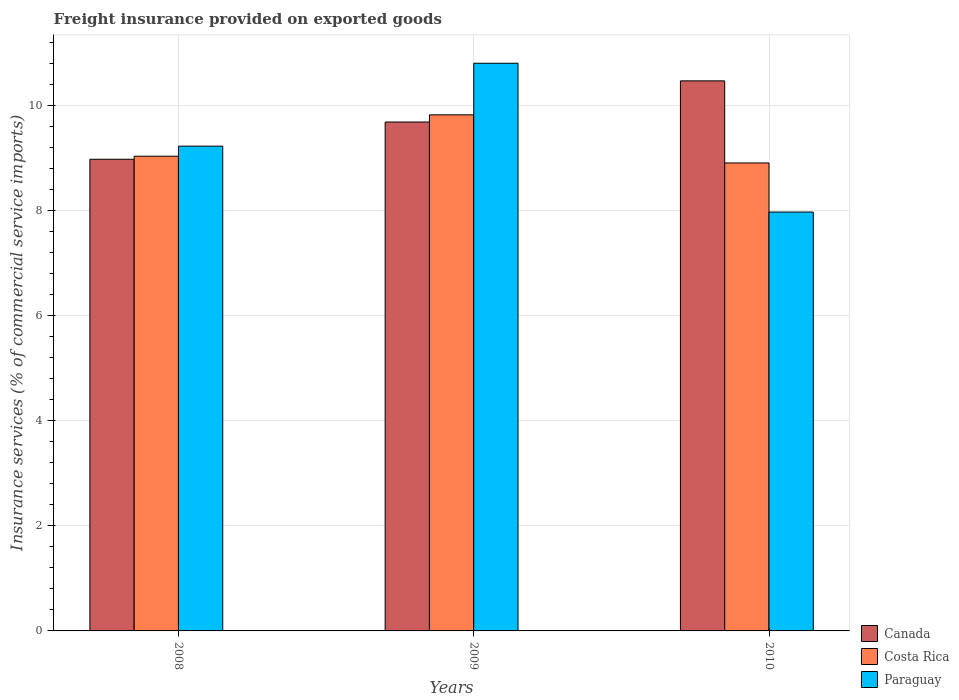Are the number of bars per tick equal to the number of legend labels?
Keep it short and to the point. Yes. Are the number of bars on each tick of the X-axis equal?
Keep it short and to the point. Yes. How many bars are there on the 2nd tick from the left?
Keep it short and to the point. 3. What is the freight insurance provided on exported goods in Canada in 2010?
Your answer should be very brief. 10.47. Across all years, what is the maximum freight insurance provided on exported goods in Canada?
Keep it short and to the point. 10.47. Across all years, what is the minimum freight insurance provided on exported goods in Costa Rica?
Your answer should be very brief. 8.91. In which year was the freight insurance provided on exported goods in Canada maximum?
Offer a very short reply. 2010. What is the total freight insurance provided on exported goods in Canada in the graph?
Your answer should be compact. 29.13. What is the difference between the freight insurance provided on exported goods in Paraguay in 2008 and that in 2009?
Provide a short and direct response. -1.58. What is the difference between the freight insurance provided on exported goods in Paraguay in 2010 and the freight insurance provided on exported goods in Costa Rica in 2009?
Provide a short and direct response. -1.85. What is the average freight insurance provided on exported goods in Paraguay per year?
Offer a very short reply. 9.34. In the year 2008, what is the difference between the freight insurance provided on exported goods in Costa Rica and freight insurance provided on exported goods in Paraguay?
Keep it short and to the point. -0.19. What is the ratio of the freight insurance provided on exported goods in Paraguay in 2008 to that in 2009?
Offer a terse response. 0.85. Is the freight insurance provided on exported goods in Canada in 2008 less than that in 2010?
Keep it short and to the point. Yes. Is the difference between the freight insurance provided on exported goods in Costa Rica in 2008 and 2010 greater than the difference between the freight insurance provided on exported goods in Paraguay in 2008 and 2010?
Your answer should be very brief. No. What is the difference between the highest and the second highest freight insurance provided on exported goods in Canada?
Make the answer very short. 0.78. What is the difference between the highest and the lowest freight insurance provided on exported goods in Paraguay?
Give a very brief answer. 2.83. Is the sum of the freight insurance provided on exported goods in Costa Rica in 2008 and 2009 greater than the maximum freight insurance provided on exported goods in Paraguay across all years?
Make the answer very short. Yes. What does the 2nd bar from the left in 2009 represents?
Make the answer very short. Costa Rica. Is it the case that in every year, the sum of the freight insurance provided on exported goods in Paraguay and freight insurance provided on exported goods in Costa Rica is greater than the freight insurance provided on exported goods in Canada?
Your answer should be compact. Yes. How many bars are there?
Ensure brevity in your answer.  9. Where does the legend appear in the graph?
Ensure brevity in your answer.  Bottom right. How many legend labels are there?
Provide a succinct answer. 3. How are the legend labels stacked?
Your answer should be very brief. Vertical. What is the title of the graph?
Give a very brief answer. Freight insurance provided on exported goods. Does "Portugal" appear as one of the legend labels in the graph?
Provide a short and direct response. No. What is the label or title of the Y-axis?
Your answer should be compact. Insurance services (% of commercial service imports). What is the Insurance services (% of commercial service imports) in Canada in 2008?
Ensure brevity in your answer.  8.98. What is the Insurance services (% of commercial service imports) in Costa Rica in 2008?
Make the answer very short. 9.04. What is the Insurance services (% of commercial service imports) of Paraguay in 2008?
Keep it short and to the point. 9.23. What is the Insurance services (% of commercial service imports) in Canada in 2009?
Your response must be concise. 9.69. What is the Insurance services (% of commercial service imports) of Costa Rica in 2009?
Provide a short and direct response. 9.82. What is the Insurance services (% of commercial service imports) of Paraguay in 2009?
Provide a short and direct response. 10.81. What is the Insurance services (% of commercial service imports) of Canada in 2010?
Your response must be concise. 10.47. What is the Insurance services (% of commercial service imports) of Costa Rica in 2010?
Your response must be concise. 8.91. What is the Insurance services (% of commercial service imports) in Paraguay in 2010?
Ensure brevity in your answer.  7.97. Across all years, what is the maximum Insurance services (% of commercial service imports) of Canada?
Ensure brevity in your answer.  10.47. Across all years, what is the maximum Insurance services (% of commercial service imports) in Costa Rica?
Keep it short and to the point. 9.82. Across all years, what is the maximum Insurance services (% of commercial service imports) in Paraguay?
Ensure brevity in your answer.  10.81. Across all years, what is the minimum Insurance services (% of commercial service imports) of Canada?
Give a very brief answer. 8.98. Across all years, what is the minimum Insurance services (% of commercial service imports) of Costa Rica?
Your answer should be compact. 8.91. Across all years, what is the minimum Insurance services (% of commercial service imports) in Paraguay?
Provide a short and direct response. 7.97. What is the total Insurance services (% of commercial service imports) of Canada in the graph?
Make the answer very short. 29.13. What is the total Insurance services (% of commercial service imports) in Costa Rica in the graph?
Your response must be concise. 27.77. What is the total Insurance services (% of commercial service imports) of Paraguay in the graph?
Make the answer very short. 28.01. What is the difference between the Insurance services (% of commercial service imports) in Canada in 2008 and that in 2009?
Provide a succinct answer. -0.71. What is the difference between the Insurance services (% of commercial service imports) in Costa Rica in 2008 and that in 2009?
Offer a very short reply. -0.79. What is the difference between the Insurance services (% of commercial service imports) in Paraguay in 2008 and that in 2009?
Provide a succinct answer. -1.58. What is the difference between the Insurance services (% of commercial service imports) of Canada in 2008 and that in 2010?
Keep it short and to the point. -1.49. What is the difference between the Insurance services (% of commercial service imports) in Costa Rica in 2008 and that in 2010?
Ensure brevity in your answer.  0.13. What is the difference between the Insurance services (% of commercial service imports) of Paraguay in 2008 and that in 2010?
Keep it short and to the point. 1.25. What is the difference between the Insurance services (% of commercial service imports) of Canada in 2009 and that in 2010?
Ensure brevity in your answer.  -0.78. What is the difference between the Insurance services (% of commercial service imports) in Costa Rica in 2009 and that in 2010?
Your response must be concise. 0.92. What is the difference between the Insurance services (% of commercial service imports) in Paraguay in 2009 and that in 2010?
Keep it short and to the point. 2.83. What is the difference between the Insurance services (% of commercial service imports) of Canada in 2008 and the Insurance services (% of commercial service imports) of Costa Rica in 2009?
Provide a short and direct response. -0.85. What is the difference between the Insurance services (% of commercial service imports) in Canada in 2008 and the Insurance services (% of commercial service imports) in Paraguay in 2009?
Make the answer very short. -1.83. What is the difference between the Insurance services (% of commercial service imports) in Costa Rica in 2008 and the Insurance services (% of commercial service imports) in Paraguay in 2009?
Offer a terse response. -1.77. What is the difference between the Insurance services (% of commercial service imports) of Canada in 2008 and the Insurance services (% of commercial service imports) of Costa Rica in 2010?
Your answer should be very brief. 0.07. What is the difference between the Insurance services (% of commercial service imports) of Costa Rica in 2008 and the Insurance services (% of commercial service imports) of Paraguay in 2010?
Your answer should be very brief. 1.06. What is the difference between the Insurance services (% of commercial service imports) of Canada in 2009 and the Insurance services (% of commercial service imports) of Costa Rica in 2010?
Provide a succinct answer. 0.78. What is the difference between the Insurance services (% of commercial service imports) in Canada in 2009 and the Insurance services (% of commercial service imports) in Paraguay in 2010?
Provide a short and direct response. 1.71. What is the difference between the Insurance services (% of commercial service imports) of Costa Rica in 2009 and the Insurance services (% of commercial service imports) of Paraguay in 2010?
Your response must be concise. 1.85. What is the average Insurance services (% of commercial service imports) of Canada per year?
Make the answer very short. 9.71. What is the average Insurance services (% of commercial service imports) of Costa Rica per year?
Provide a short and direct response. 9.26. What is the average Insurance services (% of commercial service imports) in Paraguay per year?
Your answer should be very brief. 9.34. In the year 2008, what is the difference between the Insurance services (% of commercial service imports) in Canada and Insurance services (% of commercial service imports) in Costa Rica?
Your answer should be very brief. -0.06. In the year 2008, what is the difference between the Insurance services (% of commercial service imports) in Canada and Insurance services (% of commercial service imports) in Paraguay?
Give a very brief answer. -0.25. In the year 2008, what is the difference between the Insurance services (% of commercial service imports) in Costa Rica and Insurance services (% of commercial service imports) in Paraguay?
Your answer should be compact. -0.19. In the year 2009, what is the difference between the Insurance services (% of commercial service imports) of Canada and Insurance services (% of commercial service imports) of Costa Rica?
Ensure brevity in your answer.  -0.14. In the year 2009, what is the difference between the Insurance services (% of commercial service imports) of Canada and Insurance services (% of commercial service imports) of Paraguay?
Provide a succinct answer. -1.12. In the year 2009, what is the difference between the Insurance services (% of commercial service imports) in Costa Rica and Insurance services (% of commercial service imports) in Paraguay?
Ensure brevity in your answer.  -0.98. In the year 2010, what is the difference between the Insurance services (% of commercial service imports) in Canada and Insurance services (% of commercial service imports) in Costa Rica?
Your answer should be very brief. 1.56. In the year 2010, what is the difference between the Insurance services (% of commercial service imports) of Canada and Insurance services (% of commercial service imports) of Paraguay?
Ensure brevity in your answer.  2.5. In the year 2010, what is the difference between the Insurance services (% of commercial service imports) in Costa Rica and Insurance services (% of commercial service imports) in Paraguay?
Keep it short and to the point. 0.93. What is the ratio of the Insurance services (% of commercial service imports) in Canada in 2008 to that in 2009?
Your answer should be compact. 0.93. What is the ratio of the Insurance services (% of commercial service imports) of Costa Rica in 2008 to that in 2009?
Give a very brief answer. 0.92. What is the ratio of the Insurance services (% of commercial service imports) in Paraguay in 2008 to that in 2009?
Give a very brief answer. 0.85. What is the ratio of the Insurance services (% of commercial service imports) of Canada in 2008 to that in 2010?
Provide a short and direct response. 0.86. What is the ratio of the Insurance services (% of commercial service imports) in Costa Rica in 2008 to that in 2010?
Give a very brief answer. 1.01. What is the ratio of the Insurance services (% of commercial service imports) in Paraguay in 2008 to that in 2010?
Provide a short and direct response. 1.16. What is the ratio of the Insurance services (% of commercial service imports) of Canada in 2009 to that in 2010?
Provide a short and direct response. 0.93. What is the ratio of the Insurance services (% of commercial service imports) of Costa Rica in 2009 to that in 2010?
Make the answer very short. 1.1. What is the ratio of the Insurance services (% of commercial service imports) of Paraguay in 2009 to that in 2010?
Provide a succinct answer. 1.36. What is the difference between the highest and the second highest Insurance services (% of commercial service imports) in Canada?
Provide a short and direct response. 0.78. What is the difference between the highest and the second highest Insurance services (% of commercial service imports) in Costa Rica?
Provide a succinct answer. 0.79. What is the difference between the highest and the second highest Insurance services (% of commercial service imports) of Paraguay?
Make the answer very short. 1.58. What is the difference between the highest and the lowest Insurance services (% of commercial service imports) of Canada?
Your answer should be very brief. 1.49. What is the difference between the highest and the lowest Insurance services (% of commercial service imports) of Costa Rica?
Make the answer very short. 0.92. What is the difference between the highest and the lowest Insurance services (% of commercial service imports) of Paraguay?
Provide a succinct answer. 2.83. 